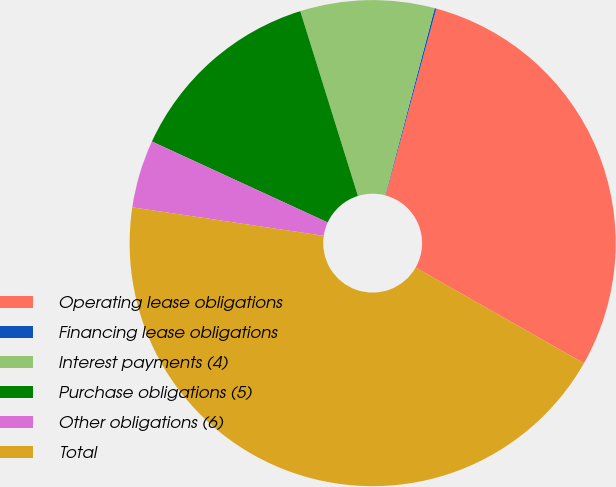<chart> <loc_0><loc_0><loc_500><loc_500><pie_chart><fcel>Operating lease obligations<fcel>Financing lease obligations<fcel>Interest payments (4)<fcel>Purchase obligations (5)<fcel>Other obligations (6)<fcel>Total<nl><fcel>29.01%<fcel>0.11%<fcel>8.92%<fcel>13.32%<fcel>4.51%<fcel>44.12%<nl></chart> 